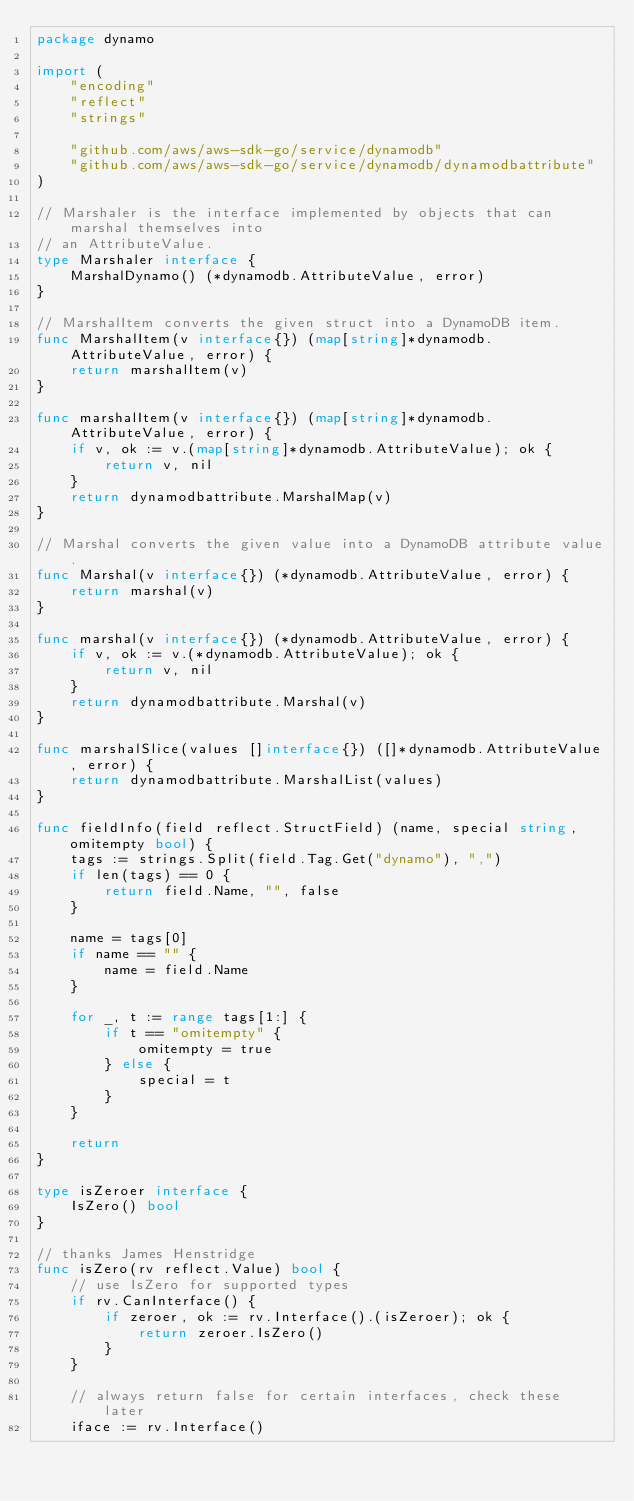<code> <loc_0><loc_0><loc_500><loc_500><_Go_>package dynamo

import (
	"encoding"
	"reflect"
	"strings"

	"github.com/aws/aws-sdk-go/service/dynamodb"
	"github.com/aws/aws-sdk-go/service/dynamodb/dynamodbattribute"
)

// Marshaler is the interface implemented by objects that can marshal themselves into
// an AttributeValue.
type Marshaler interface {
	MarshalDynamo() (*dynamodb.AttributeValue, error)
}

// MarshalItem converts the given struct into a DynamoDB item.
func MarshalItem(v interface{}) (map[string]*dynamodb.AttributeValue, error) {
	return marshalItem(v)
}

func marshalItem(v interface{}) (map[string]*dynamodb.AttributeValue, error) {
	if v, ok := v.(map[string]*dynamodb.AttributeValue); ok {
		return v, nil
	}
	return dynamodbattribute.MarshalMap(v)
}

// Marshal converts the given value into a DynamoDB attribute value.
func Marshal(v interface{}) (*dynamodb.AttributeValue, error) {
	return marshal(v)
}

func marshal(v interface{}) (*dynamodb.AttributeValue, error) {
	if v, ok := v.(*dynamodb.AttributeValue); ok {
		return v, nil
	}
	return dynamodbattribute.Marshal(v)
}

func marshalSlice(values []interface{}) ([]*dynamodb.AttributeValue, error) {
	return dynamodbattribute.MarshalList(values)
}

func fieldInfo(field reflect.StructField) (name, special string, omitempty bool) {
	tags := strings.Split(field.Tag.Get("dynamo"), ",")
	if len(tags) == 0 {
		return field.Name, "", false
	}

	name = tags[0]
	if name == "" {
		name = field.Name
	}

	for _, t := range tags[1:] {
		if t == "omitempty" {
			omitempty = true
		} else {
			special = t
		}
	}

	return
}

type isZeroer interface {
	IsZero() bool
}

// thanks James Henstridge
func isZero(rv reflect.Value) bool {
	// use IsZero for supported types
	if rv.CanInterface() {
		if zeroer, ok := rv.Interface().(isZeroer); ok {
			return zeroer.IsZero()
		}
	}

	// always return false for certain interfaces, check these later
	iface := rv.Interface()</code> 